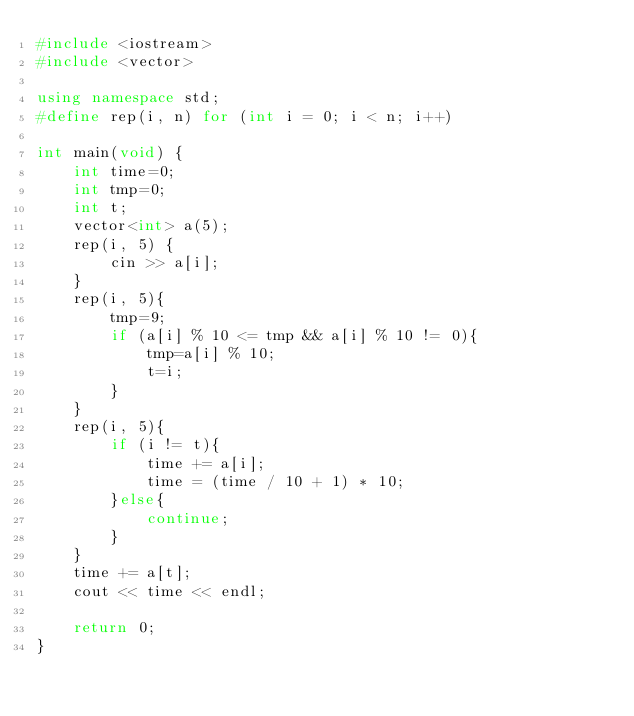Convert code to text. <code><loc_0><loc_0><loc_500><loc_500><_C++_>#include <iostream>
#include <vector>

using namespace std;
#define rep(i, n) for (int i = 0; i < n; i++)
 
int main(void) {
    int time=0;
    int tmp=0;
    int t;
    vector<int> a(5);
    rep(i, 5) {
        cin >> a[i];
    }
    rep(i, 5){
        tmp=9;
        if (a[i] % 10 <= tmp && a[i] % 10 != 0){
            tmp=a[i] % 10;
            t=i;
        }
    }
    rep(i, 5){
        if (i != t){
            time += a[i];
            time = (time / 10 + 1) * 10;
        }else{
            continue;
        }   
    }
    time += a[t];
    cout << time << endl;
 
    return 0;
}</code> 